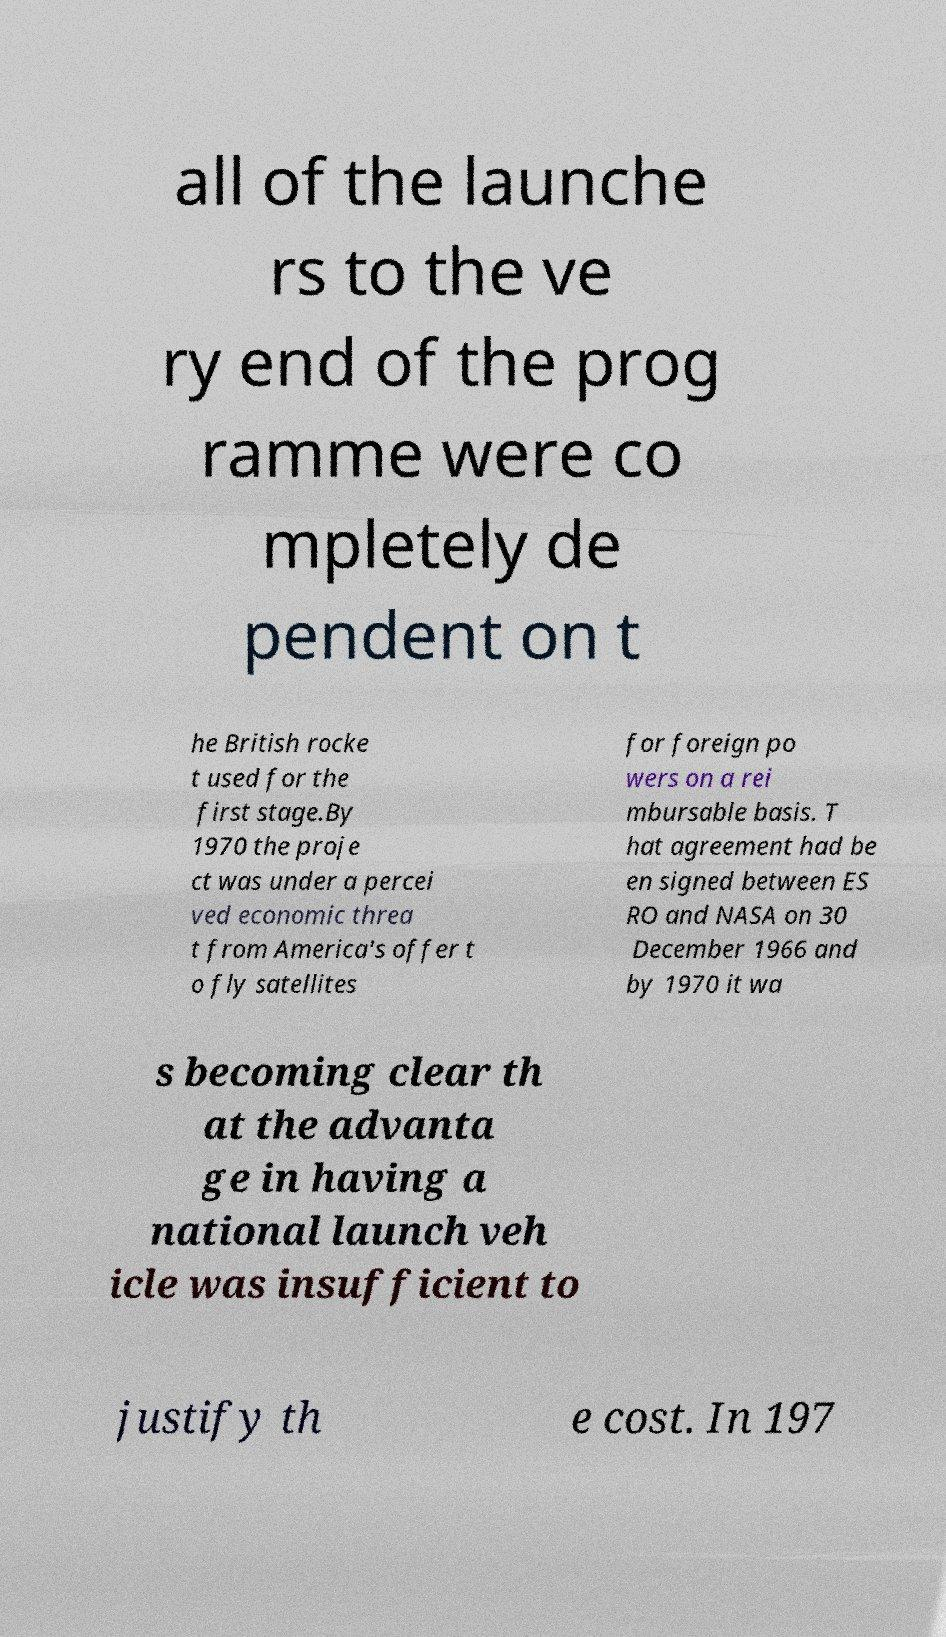I need the written content from this picture converted into text. Can you do that? all of the launche rs to the ve ry end of the prog ramme were co mpletely de pendent on t he British rocke t used for the first stage.By 1970 the proje ct was under a percei ved economic threa t from America's offer t o fly satellites for foreign po wers on a rei mbursable basis. T hat agreement had be en signed between ES RO and NASA on 30 December 1966 and by 1970 it wa s becoming clear th at the advanta ge in having a national launch veh icle was insufficient to justify th e cost. In 197 